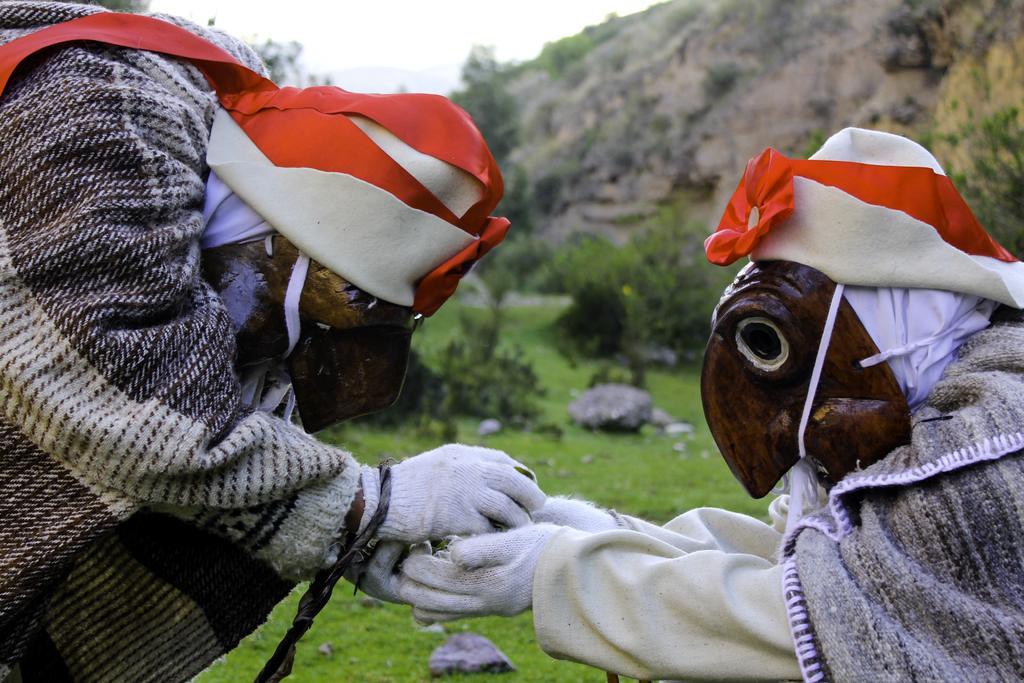Can you describe this image briefly? In this image I can see two persons with the costumes. In the background I can see few trees in green color, mountains and the sky is in white color. 